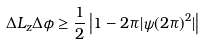Convert formula to latex. <formula><loc_0><loc_0><loc_500><loc_500>\Delta L _ { z } \Delta \phi \geq \frac { 1 } { 2 } \left | 1 - 2 \pi | \psi ( 2 \pi ) ^ { 2 } | \right |</formula> 